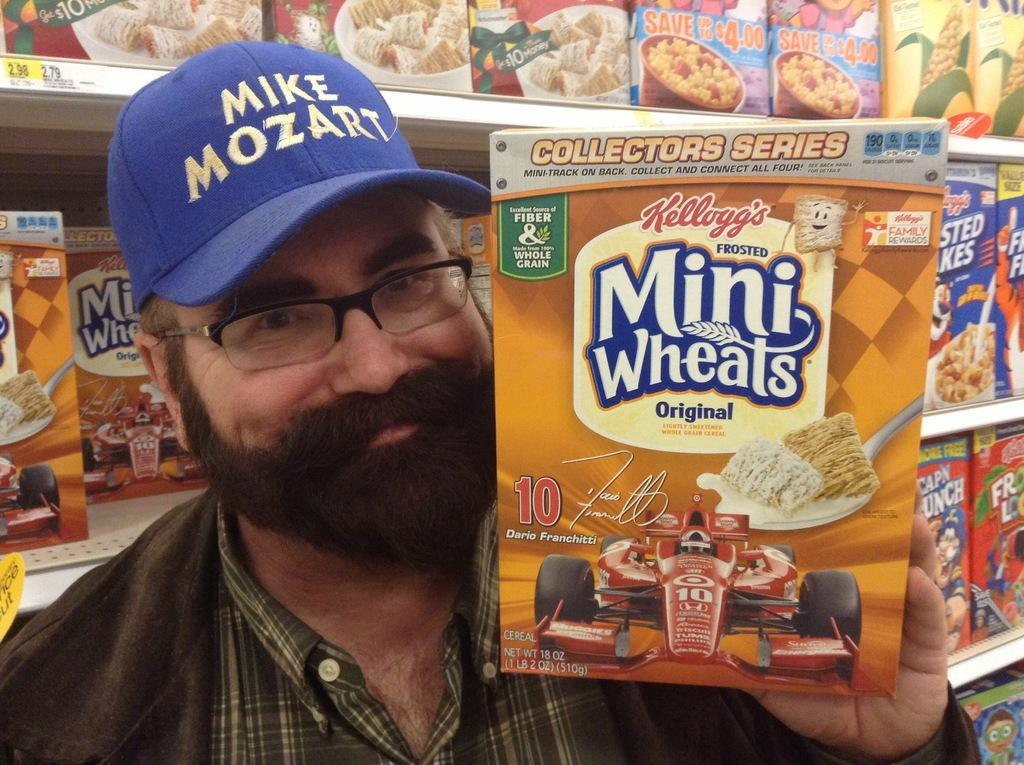What is the man in the image wearing on his head? The man is wearing a cap. What else is the man wearing in the image? The man is wearing spectacles. What is the man holding in the image? The man is holding a box with his hand. What is the man's facial expression in the image? The man is smiling. What can be seen in the background of the image? There are boxes on shelves in the background of the image. Can you tell me how many cent coins are on the playground in the image? There is no playground or cent coins present in the image. Is the man standing in quicksand in the image? There is no quicksand present in the image; the man is holding a box and standing on a solid surface. 